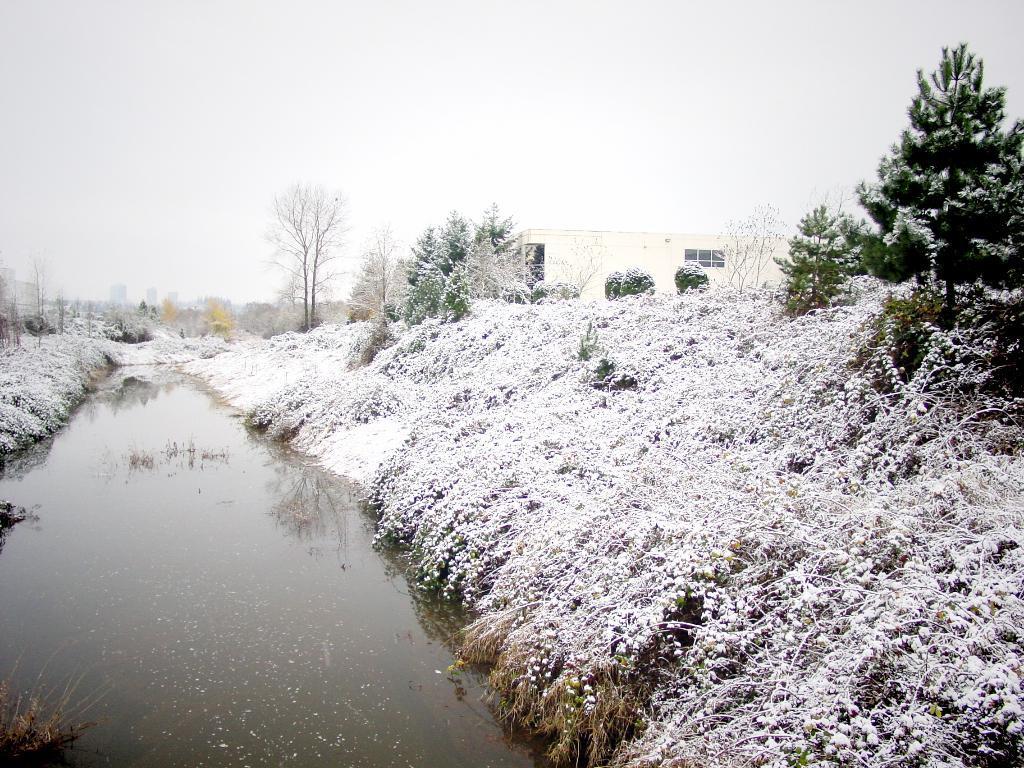Please provide a concise description of this image. In this picture we can see water, snow, trees and building. Behind the building there is a sky. 